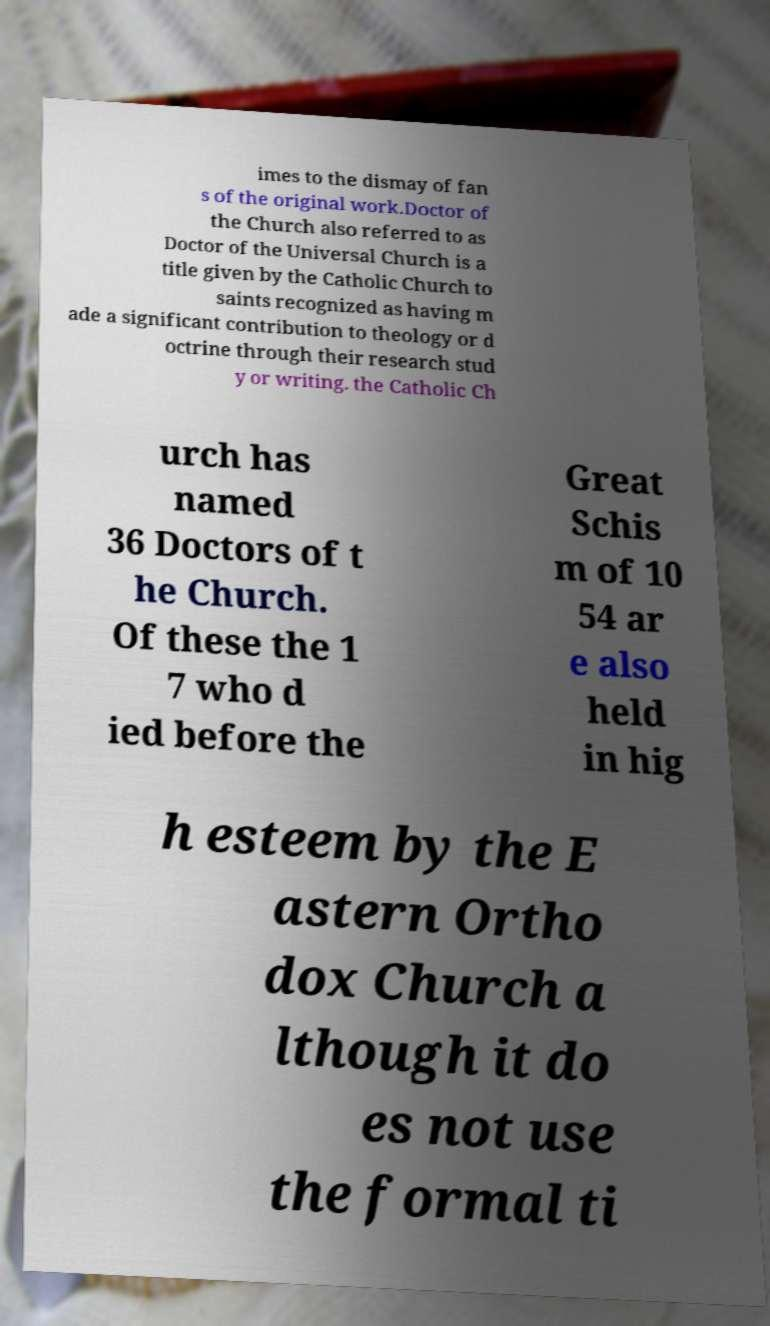Please read and relay the text visible in this image. What does it say? imes to the dismay of fan s of the original work.Doctor of the Church also referred to as Doctor of the Universal Church is a title given by the Catholic Church to saints recognized as having m ade a significant contribution to theology or d octrine through their research stud y or writing. the Catholic Ch urch has named 36 Doctors of t he Church. Of these the 1 7 who d ied before the Great Schis m of 10 54 ar e also held in hig h esteem by the E astern Ortho dox Church a lthough it do es not use the formal ti 